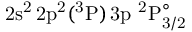<formula> <loc_0><loc_0><loc_500><loc_500>2 s ^ { 2 } \, 2 p ^ { 2 } ( ^ { 3 } P ) \, 3 p ^ { 2 } P _ { 3 / 2 } ^ { \circ }</formula> 